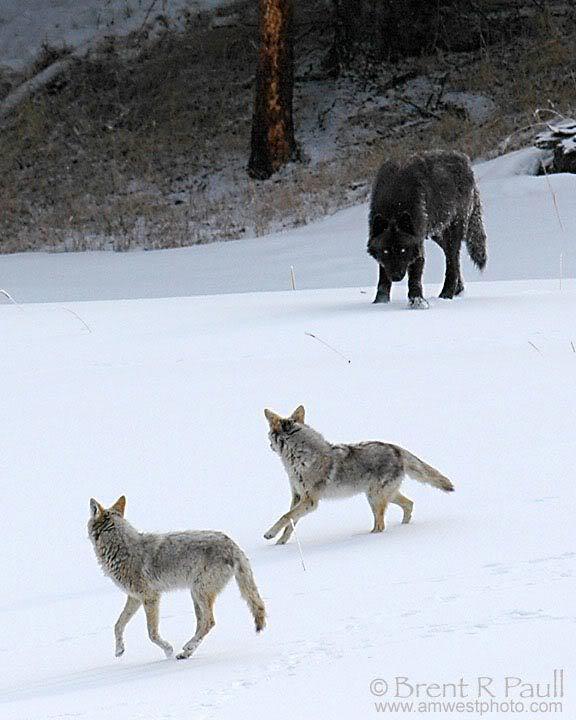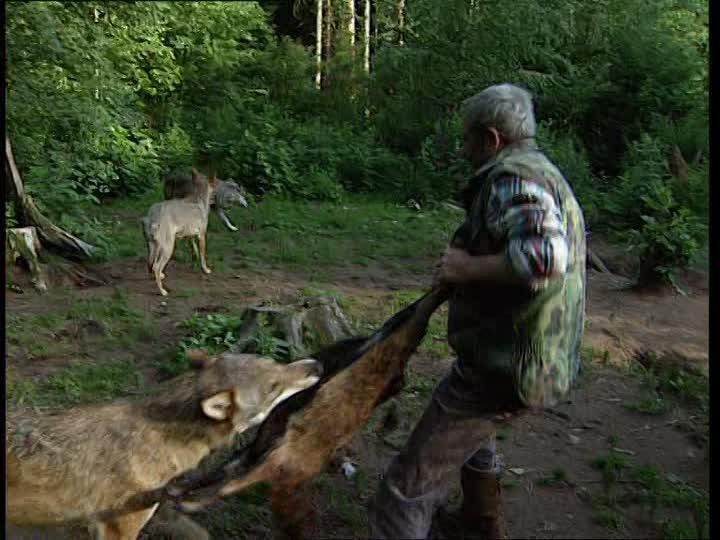The first image is the image on the left, the second image is the image on the right. Considering the images on both sides, is "The left image contains no more than two wolves." valid? Answer yes or no. No. 